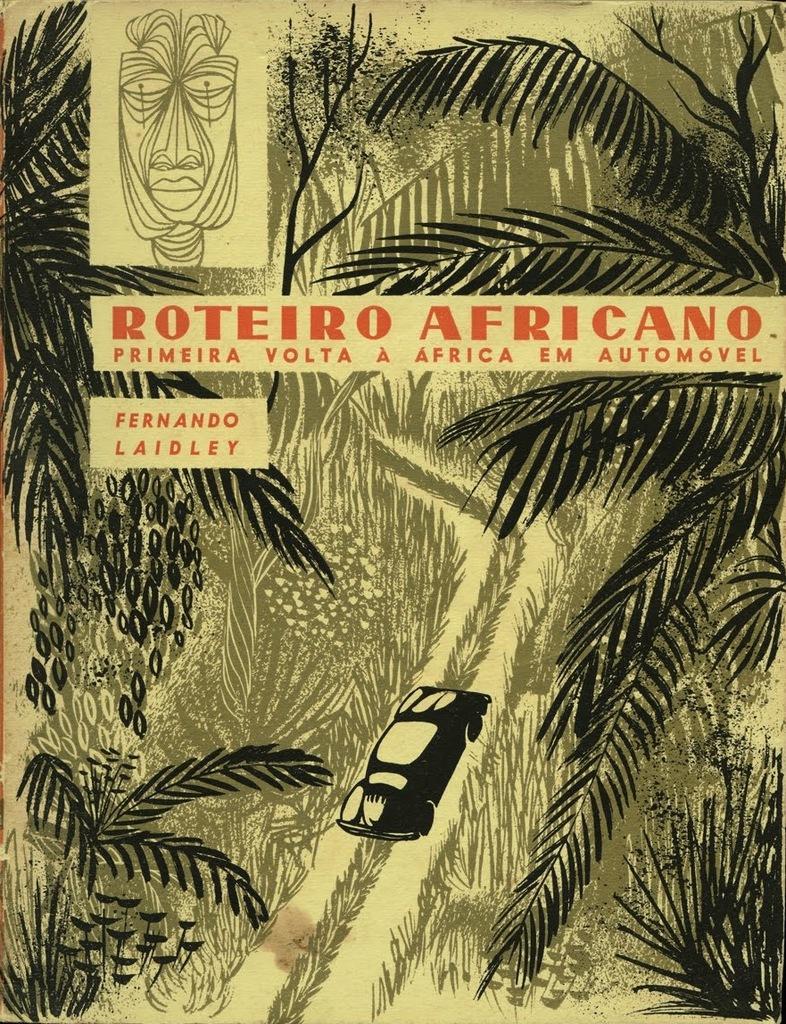Could you give a brief overview of what you see in this image? In this image I can see the depiction picture. In that picture I can see number of trees and on the bottom side of the image I can see a black color car. I can also see something is written on the top side of the image. 